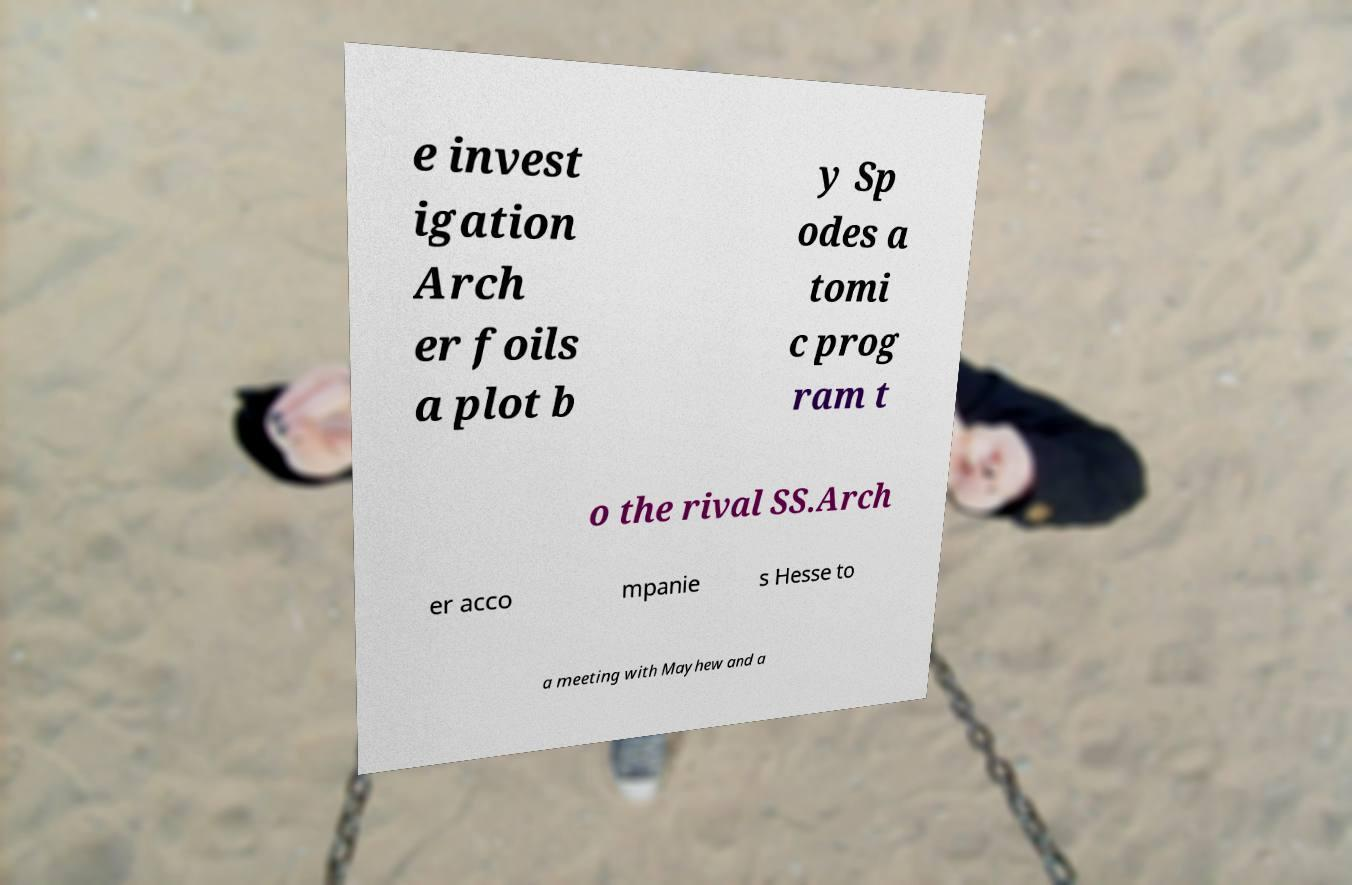For documentation purposes, I need the text within this image transcribed. Could you provide that? e invest igation Arch er foils a plot b y Sp odes a tomi c prog ram t o the rival SS.Arch er acco mpanie s Hesse to a meeting with Mayhew and a 